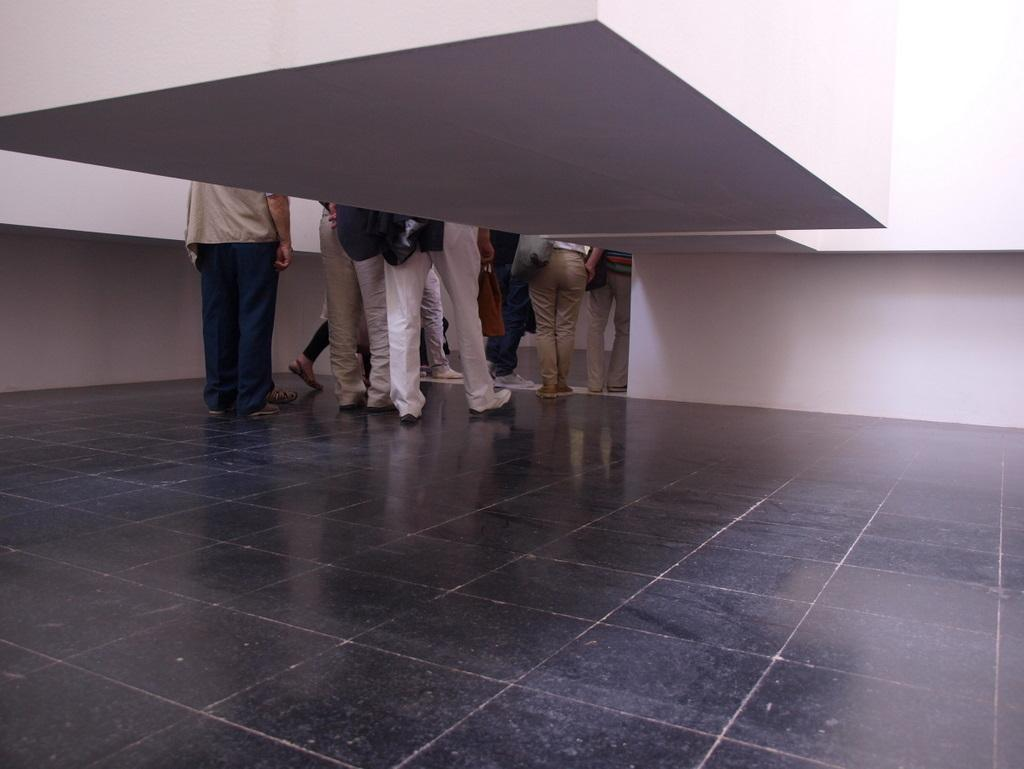What is visible in the foreground of the image? There are legs of a person in the foreground of the image. What is the position of the legs in relation to an object? The legs are behind an object. What can be seen at the bottom of the image? The floor is visible at the bottom of the image. What type of disgust can be seen on the person's face in the image? There is no face visible in the image, only the legs of a person. Therefore, it is not possible to determine any emotions or expressions. 